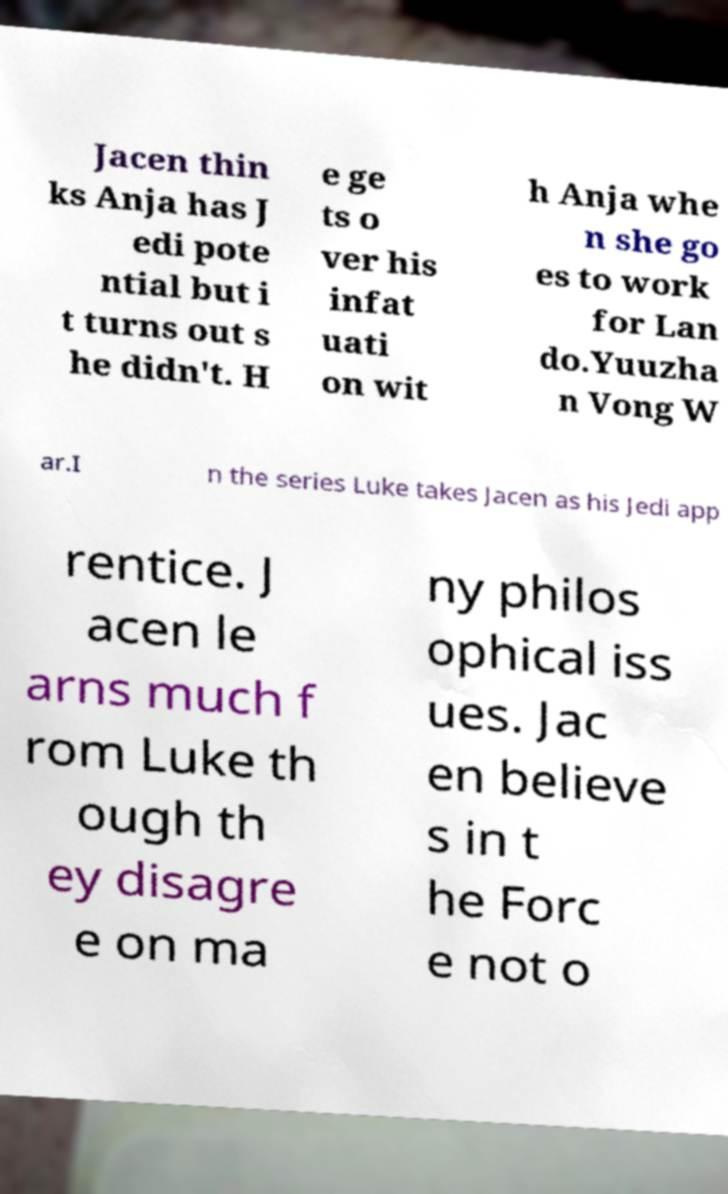Could you extract and type out the text from this image? Jacen thin ks Anja has J edi pote ntial but i t turns out s he didn't. H e ge ts o ver his infat uati on wit h Anja whe n she go es to work for Lan do.Yuuzha n Vong W ar.I n the series Luke takes Jacen as his Jedi app rentice. J acen le arns much f rom Luke th ough th ey disagre e on ma ny philos ophical iss ues. Jac en believe s in t he Forc e not o 